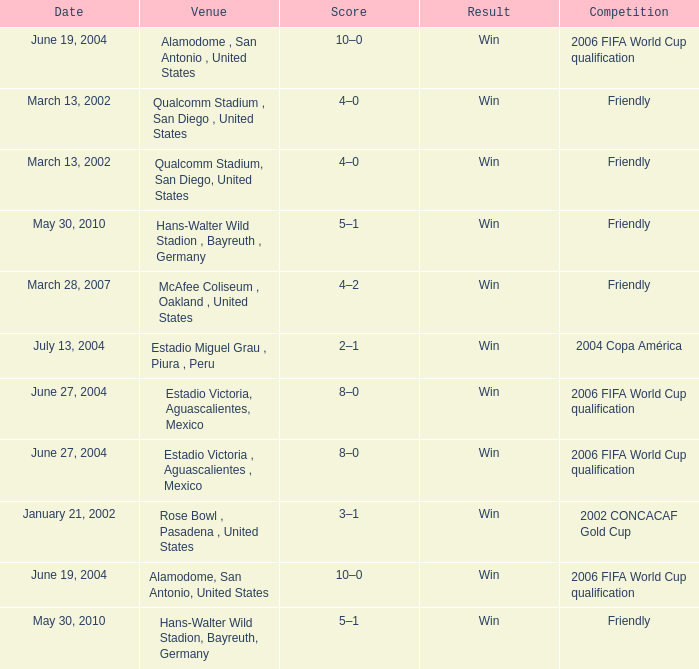What result has January 21, 2002 as the date? Win. 